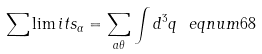<formula> <loc_0><loc_0><loc_500><loc_500>\sum \lim i t s _ { \alpha } = \sum _ { a \theta } \int d ^ { 3 } q \ e q n u m { 6 8 }</formula> 